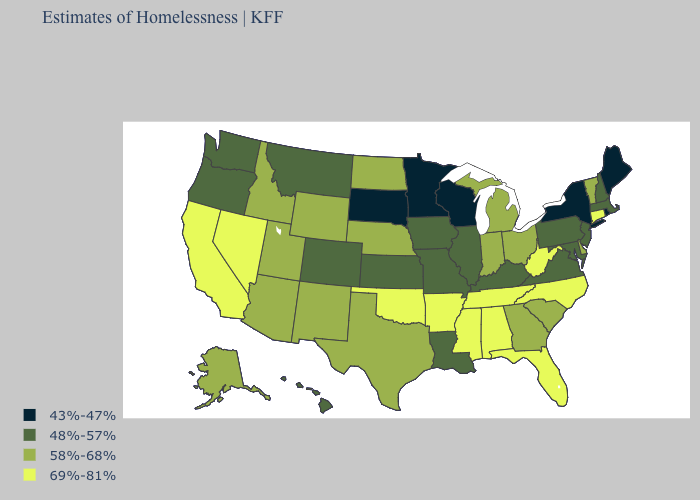What is the value of New Mexico?
Keep it brief. 58%-68%. What is the highest value in the Northeast ?
Write a very short answer. 69%-81%. What is the value of Tennessee?
Give a very brief answer. 69%-81%. Does the map have missing data?
Short answer required. No. How many symbols are there in the legend?
Quick response, please. 4. How many symbols are there in the legend?
Short answer required. 4. Does Iowa have a higher value than Kansas?
Keep it brief. No. Does Nevada have the highest value in the USA?
Be succinct. Yes. Name the states that have a value in the range 48%-57%?
Quick response, please. Colorado, Hawaii, Illinois, Iowa, Kansas, Kentucky, Louisiana, Maryland, Massachusetts, Missouri, Montana, New Hampshire, New Jersey, Oregon, Pennsylvania, Virginia, Washington. How many symbols are there in the legend?
Give a very brief answer. 4. What is the value of New Jersey?
Write a very short answer. 48%-57%. What is the value of Ohio?
Quick response, please. 58%-68%. Does the first symbol in the legend represent the smallest category?
Be succinct. Yes. What is the highest value in the USA?
Quick response, please. 69%-81%. Does New York have the lowest value in the USA?
Write a very short answer. Yes. 